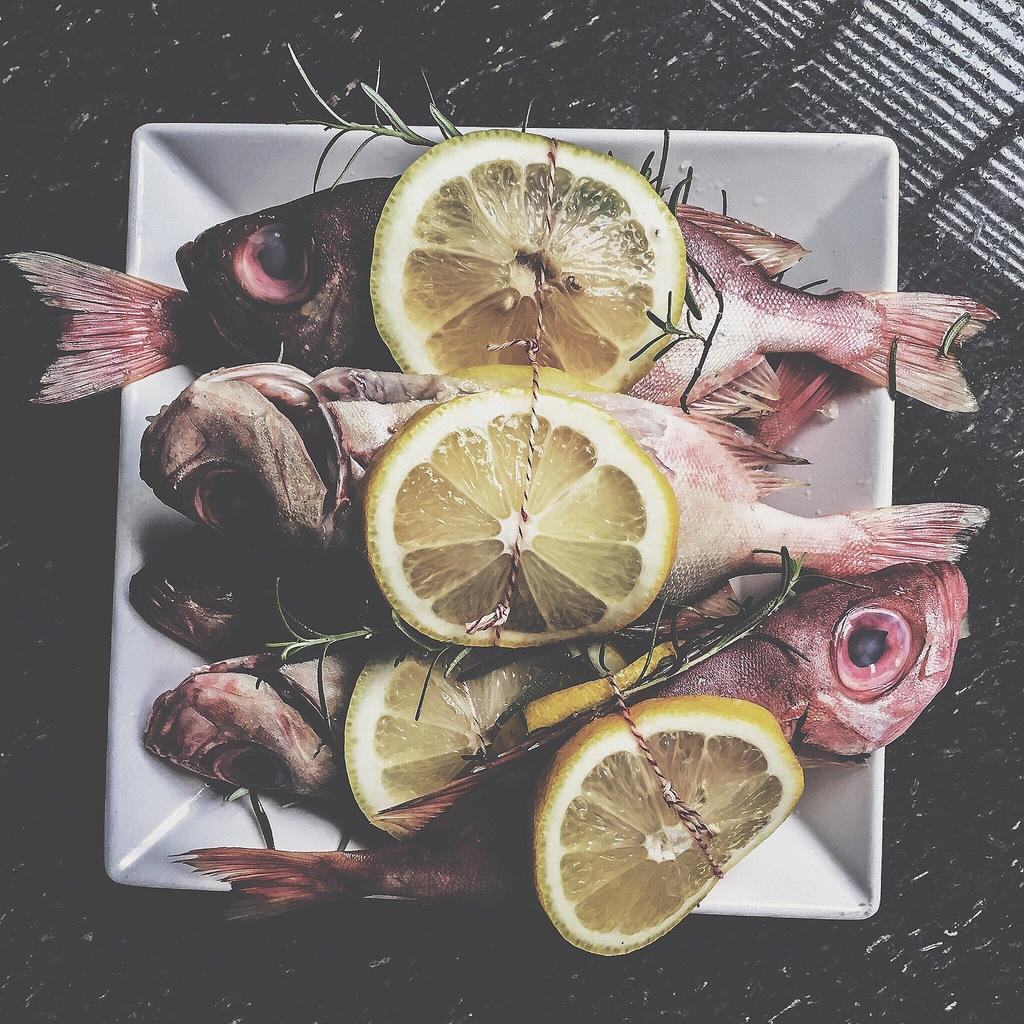What type of animals can be seen in the image? There are fishes in the image. What type of fruit is present in the image? There are lemons in the image. What is the color of the plate in the image? The plate is in white color. Can you see a swing in the image? There is no swing present in the image. Are there any visible teeth on the fishes in the image? Fishes do not have teeth like humans, so there are no visible teeth on the fishes in the image. 